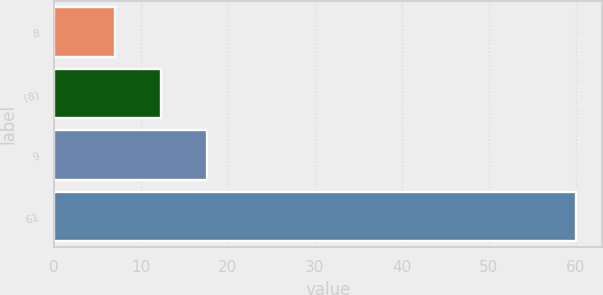Convert chart to OTSL. <chart><loc_0><loc_0><loc_500><loc_500><bar_chart><fcel>8<fcel>(8)<fcel>9<fcel>61<nl><fcel>7<fcel>12.3<fcel>17.6<fcel>60<nl></chart> 